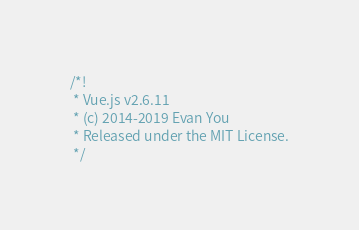Convert code to text. <code><loc_0><loc_0><loc_500><loc_500><_JavaScript_>/*!
 * Vue.js v2.6.11
 * (c) 2014-2019 Evan You
 * Released under the MIT License.
 */</code> 